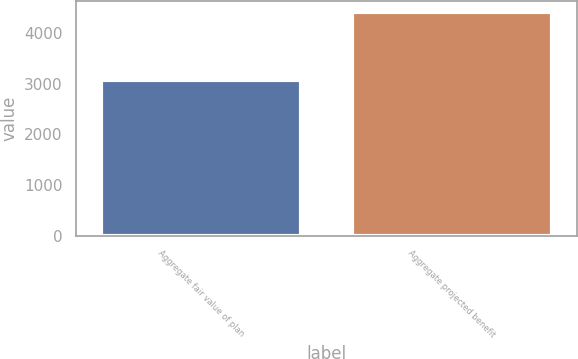<chart> <loc_0><loc_0><loc_500><loc_500><bar_chart><fcel>Aggregate fair value of plan<fcel>Aggregate projected benefit<nl><fcel>3070<fcel>4408<nl></chart> 